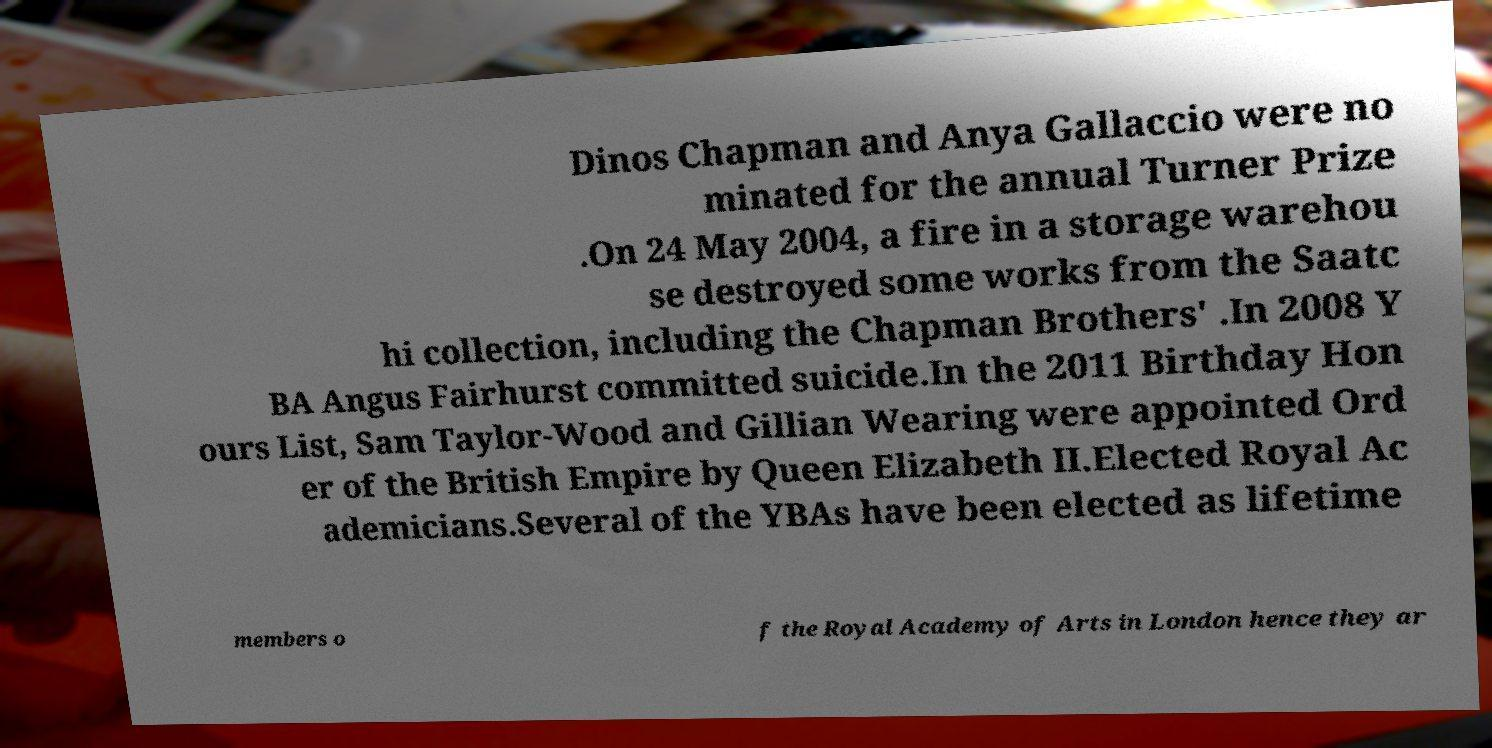Can you accurately transcribe the text from the provided image for me? Dinos Chapman and Anya Gallaccio were no minated for the annual Turner Prize .On 24 May 2004, a fire in a storage warehou se destroyed some works from the Saatc hi collection, including the Chapman Brothers' .In 2008 Y BA Angus Fairhurst committed suicide.In the 2011 Birthday Hon ours List, Sam Taylor-Wood and Gillian Wearing were appointed Ord er of the British Empire by Queen Elizabeth II.Elected Royal Ac ademicians.Several of the YBAs have been elected as lifetime members o f the Royal Academy of Arts in London hence they ar 